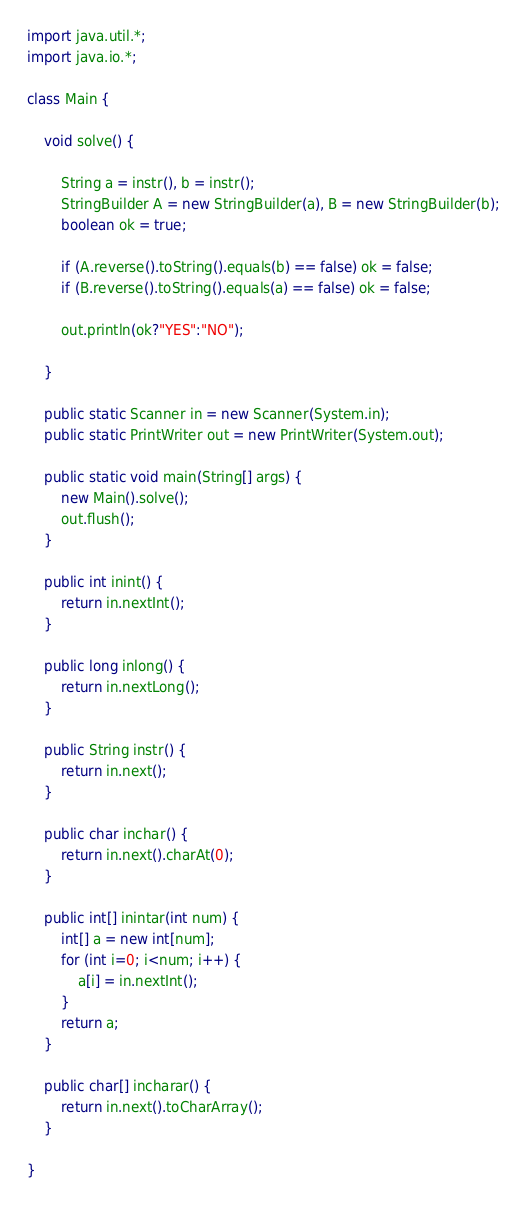Convert code to text. <code><loc_0><loc_0><loc_500><loc_500><_Java_>import java.util.*;
import java.io.*;

class Main {

	void solve() {
		
		String a = instr(), b = instr();
		StringBuilder A = new StringBuilder(a), B = new StringBuilder(b);
		boolean ok = true;
		
		if (A.reverse().toString().equals(b) == false) ok = false;
		if (B.reverse().toString().equals(a) == false) ok = false;
		
		out.println(ok?"YES":"NO");
		
	}

	public static Scanner in = new Scanner(System.in);
	public static PrintWriter out = new PrintWriter(System.out);

	public static void main(String[] args) {
		new Main().solve();
		out.flush();
	}

	public int inint() {
		return in.nextInt();
	}

	public long inlong() {
		return in.nextLong();
	}
	
	public String instr() {
		return in.next();
	}

	public char inchar() {
		return in.next().charAt(0);
	}
	
	public int[] inintar(int num) {
		int[] a = new int[num];
		for (int i=0; i<num; i++) {
			a[i] = in.nextInt();
		}
		return a;
	}

	public char[] incharar() {
		return in.next().toCharArray();
	}

}</code> 